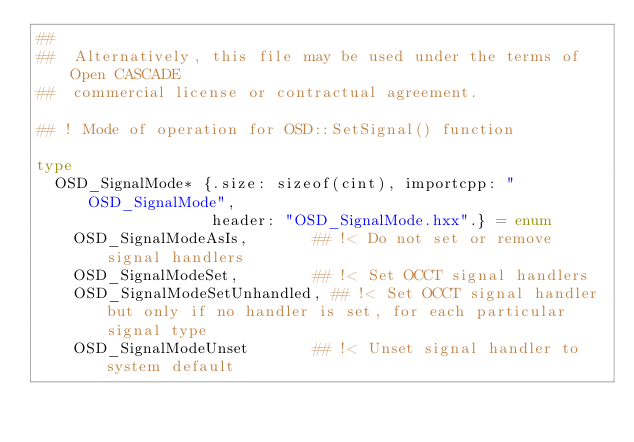<code> <loc_0><loc_0><loc_500><loc_500><_Nim_>##
##  Alternatively, this file may be used under the terms of Open CASCADE
##  commercial license or contractual agreement.

## ! Mode of operation for OSD::SetSignal() function

type
  OSD_SignalMode* {.size: sizeof(cint), importcpp: "OSD_SignalMode",
                   header: "OSD_SignalMode.hxx".} = enum
    OSD_SignalModeAsIs,       ## !< Do not set or remove signal handlers
    OSD_SignalModeSet,        ## !< Set OCCT signal handlers
    OSD_SignalModeSetUnhandled, ## !< Set OCCT signal handler but only if no handler is set, for each particular signal type
    OSD_SignalModeUnset       ## !< Unset signal handler to system default



























</code> 